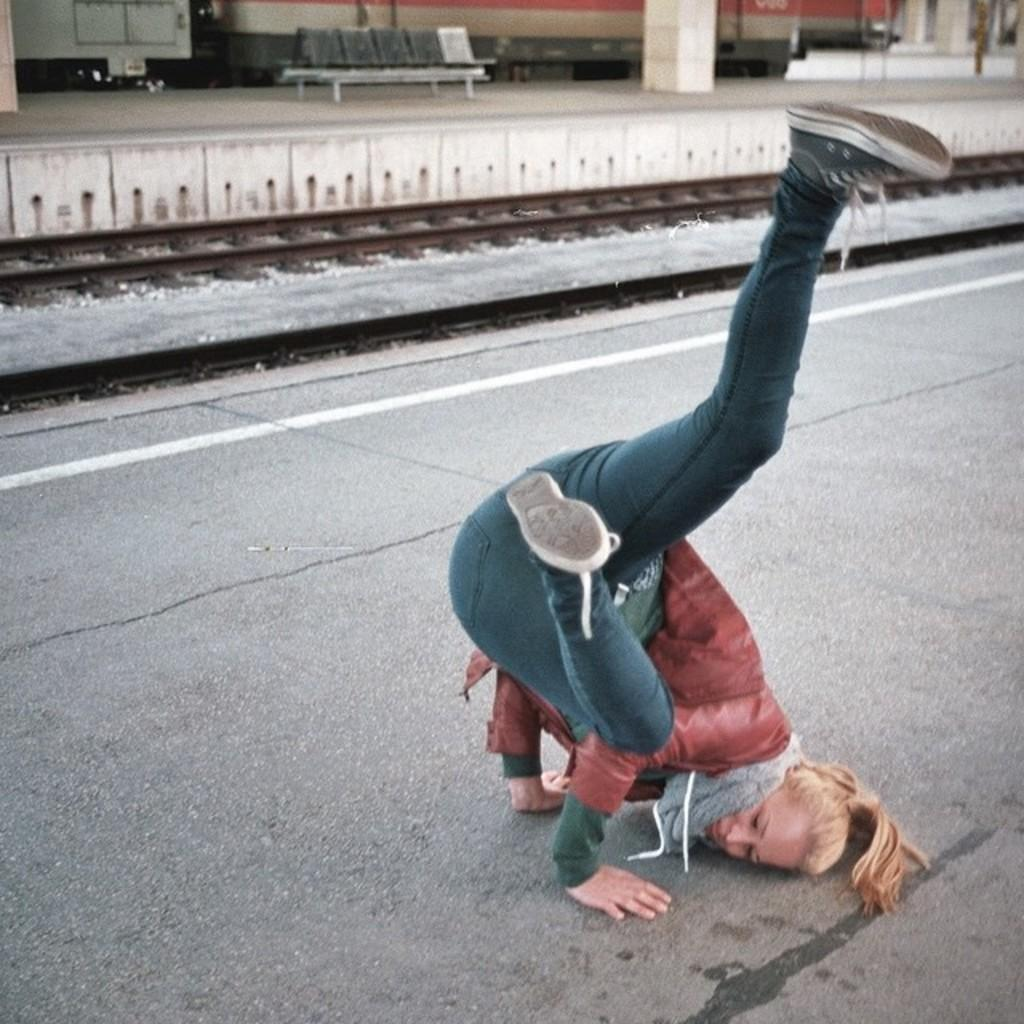What is the main subject in the center of the image? There is a person on a platform in the center of the image. What can be seen in the background of the image? There is a wall, railway tracks, attached chairs, pillars, and a few other objects in the background. Can you describe the platform the person is standing on? The platform is in the center of the image, and the person is standing on it. How many grains of rice can be seen on the person's clothing in the image? There is no rice or grains visible on the person's clothing in the image. Are there any mice present in the image? There are no mice visible in the image. 